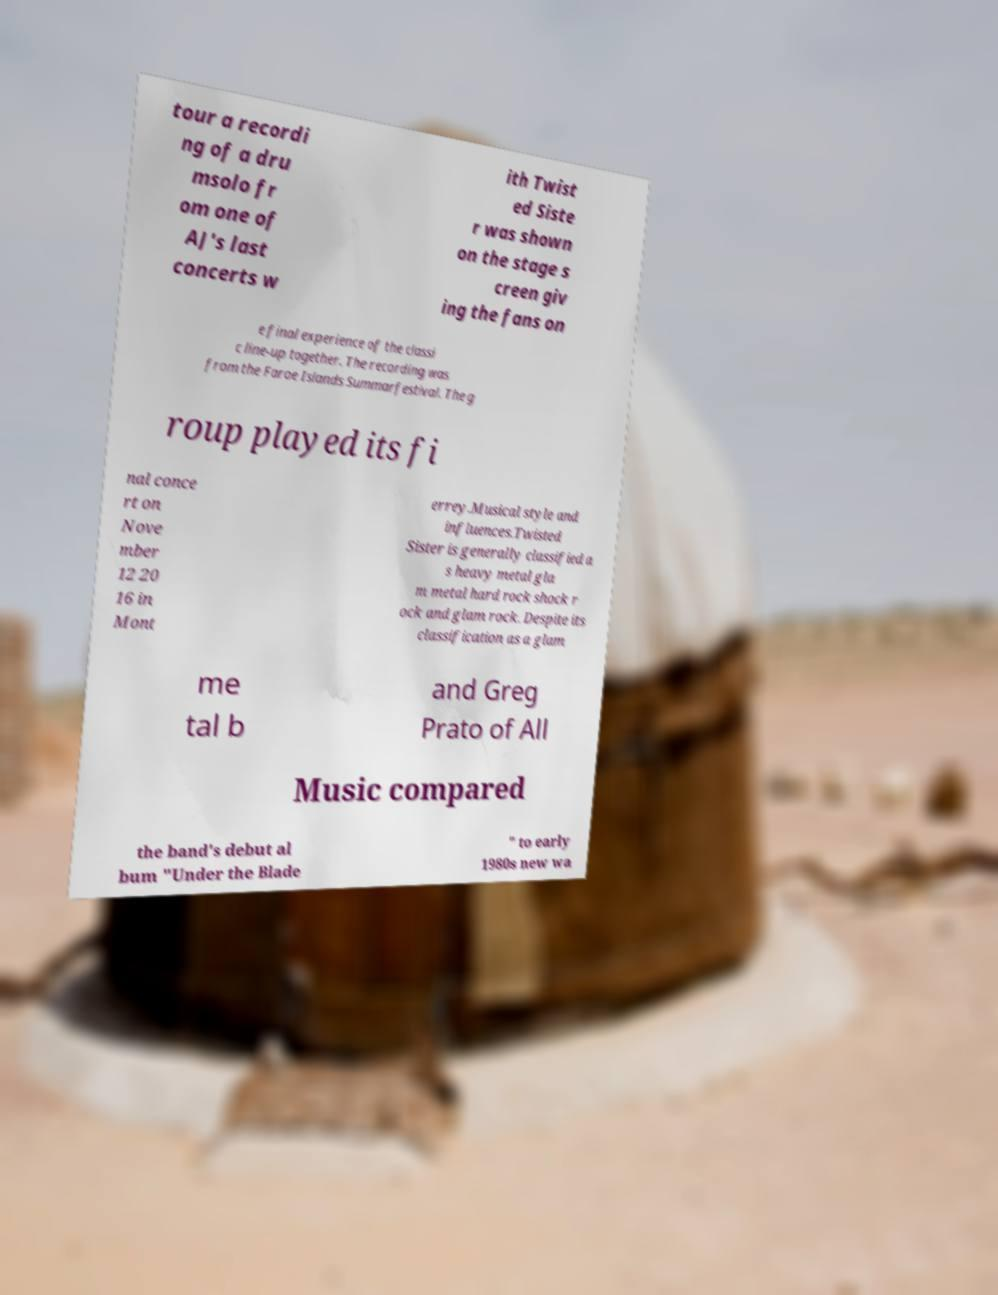For documentation purposes, I need the text within this image transcribed. Could you provide that? tour a recordi ng of a dru msolo fr om one of AJ's last concerts w ith Twist ed Siste r was shown on the stage s creen giv ing the fans on e final experience of the classi c line-up together. The recording was from the Faroe Islands Summarfestival. The g roup played its fi nal conce rt on Nove mber 12 20 16 in Mont errey.Musical style and influences.Twisted Sister is generally classified a s heavy metal gla m metal hard rock shock r ock and glam rock. Despite its classification as a glam me tal b and Greg Prato of All Music compared the band's debut al bum "Under the Blade " to early 1980s new wa 